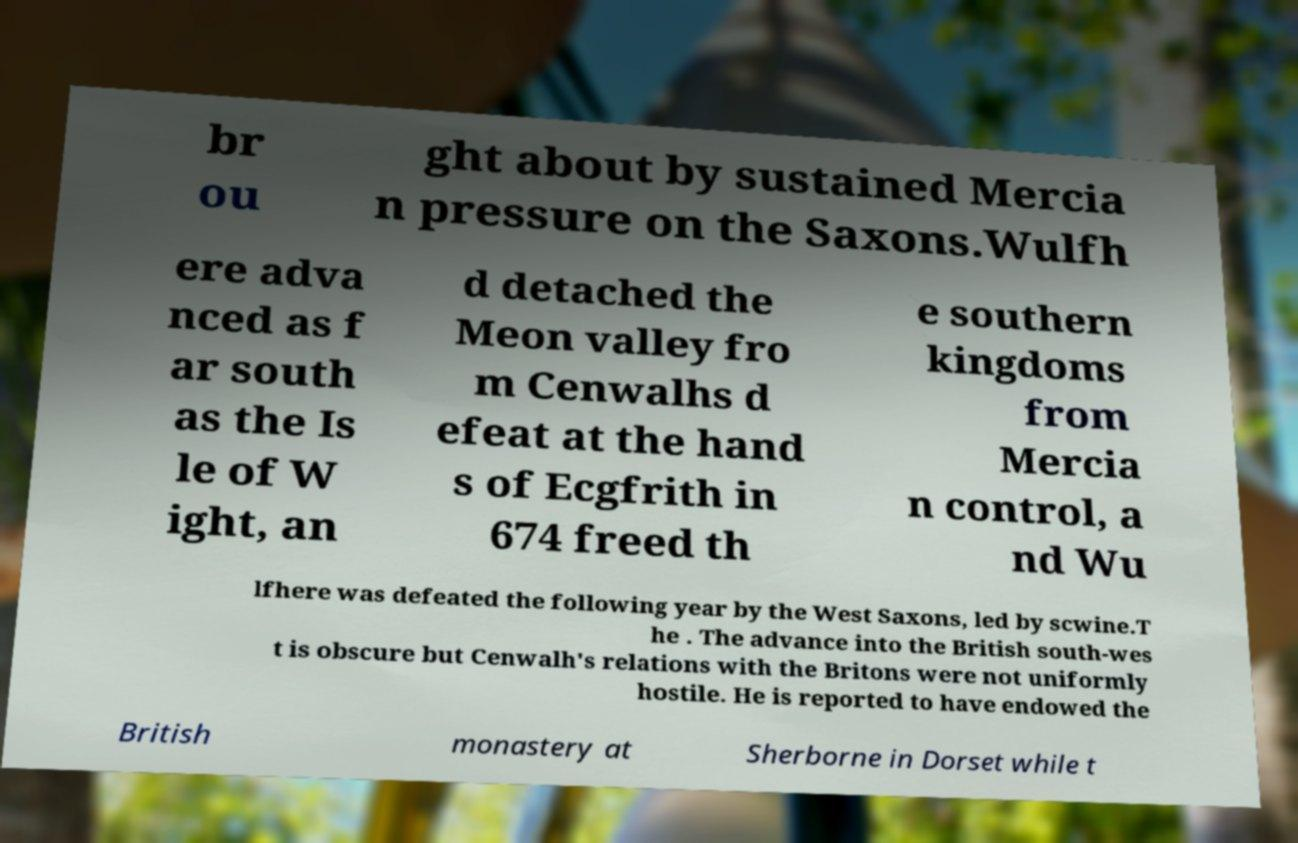Could you extract and type out the text from this image? br ou ght about by sustained Mercia n pressure on the Saxons.Wulfh ere adva nced as f ar south as the Is le of W ight, an d detached the Meon valley fro m Cenwalhs d efeat at the hand s of Ecgfrith in 674 freed th e southern kingdoms from Mercia n control, a nd Wu lfhere was defeated the following year by the West Saxons, led by scwine.T he . The advance into the British south-wes t is obscure but Cenwalh's relations with the Britons were not uniformly hostile. He is reported to have endowed the British monastery at Sherborne in Dorset while t 